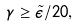<formula> <loc_0><loc_0><loc_500><loc_500>\gamma \geq \tilde { \epsilon } / 2 0 ,</formula> 